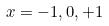<formula> <loc_0><loc_0><loc_500><loc_500>x = - 1 , 0 , + 1</formula> 